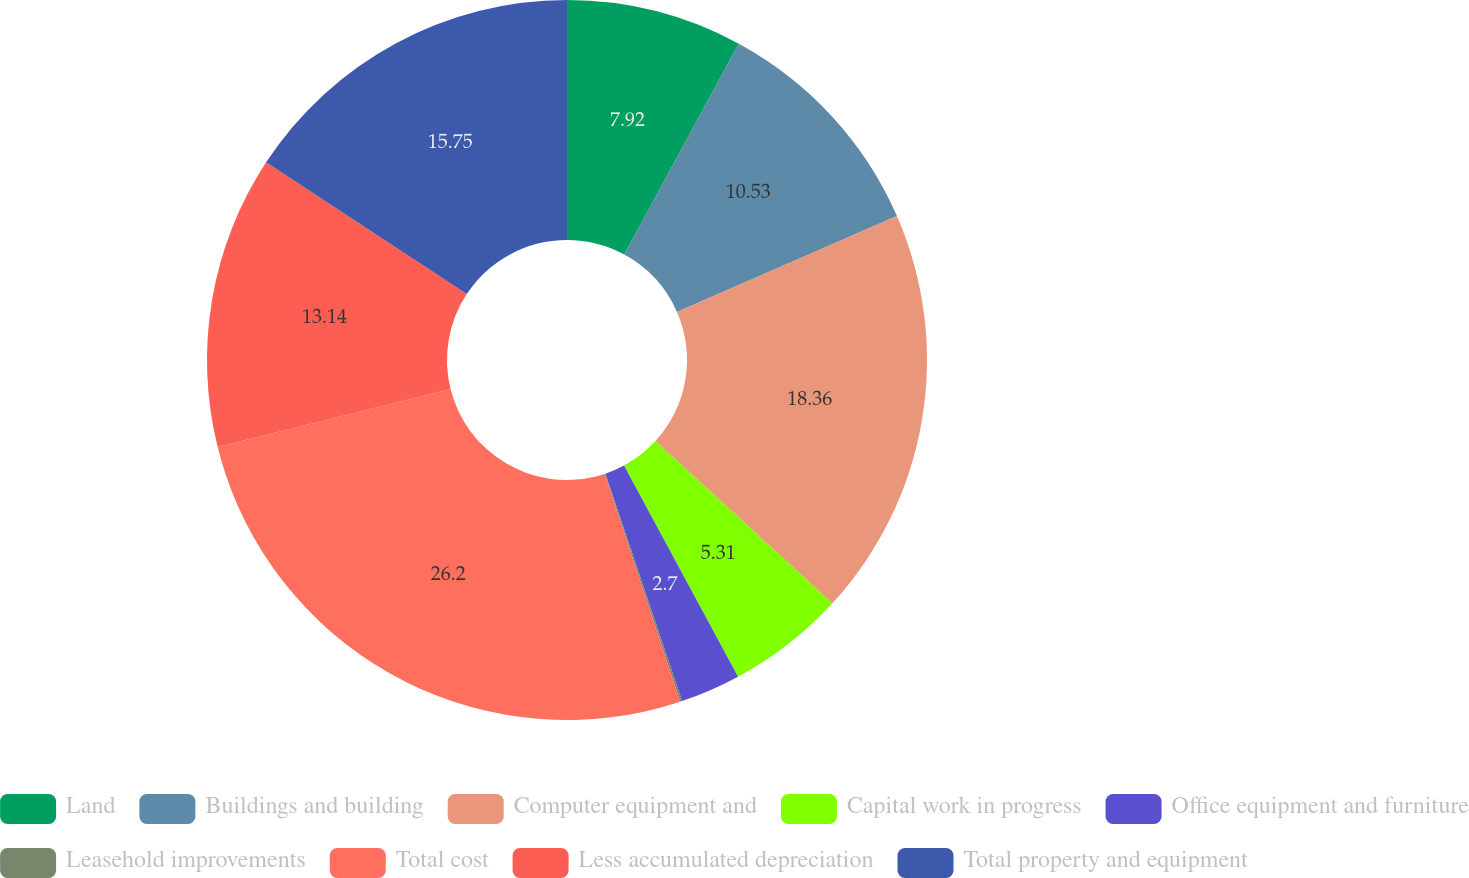Convert chart to OTSL. <chart><loc_0><loc_0><loc_500><loc_500><pie_chart><fcel>Land<fcel>Buildings and building<fcel>Computer equipment and<fcel>Capital work in progress<fcel>Office equipment and furniture<fcel>Leasehold improvements<fcel>Total cost<fcel>Less accumulated depreciation<fcel>Total property and equipment<nl><fcel>7.92%<fcel>10.53%<fcel>18.36%<fcel>5.31%<fcel>2.7%<fcel>0.09%<fcel>26.2%<fcel>13.14%<fcel>15.75%<nl></chart> 